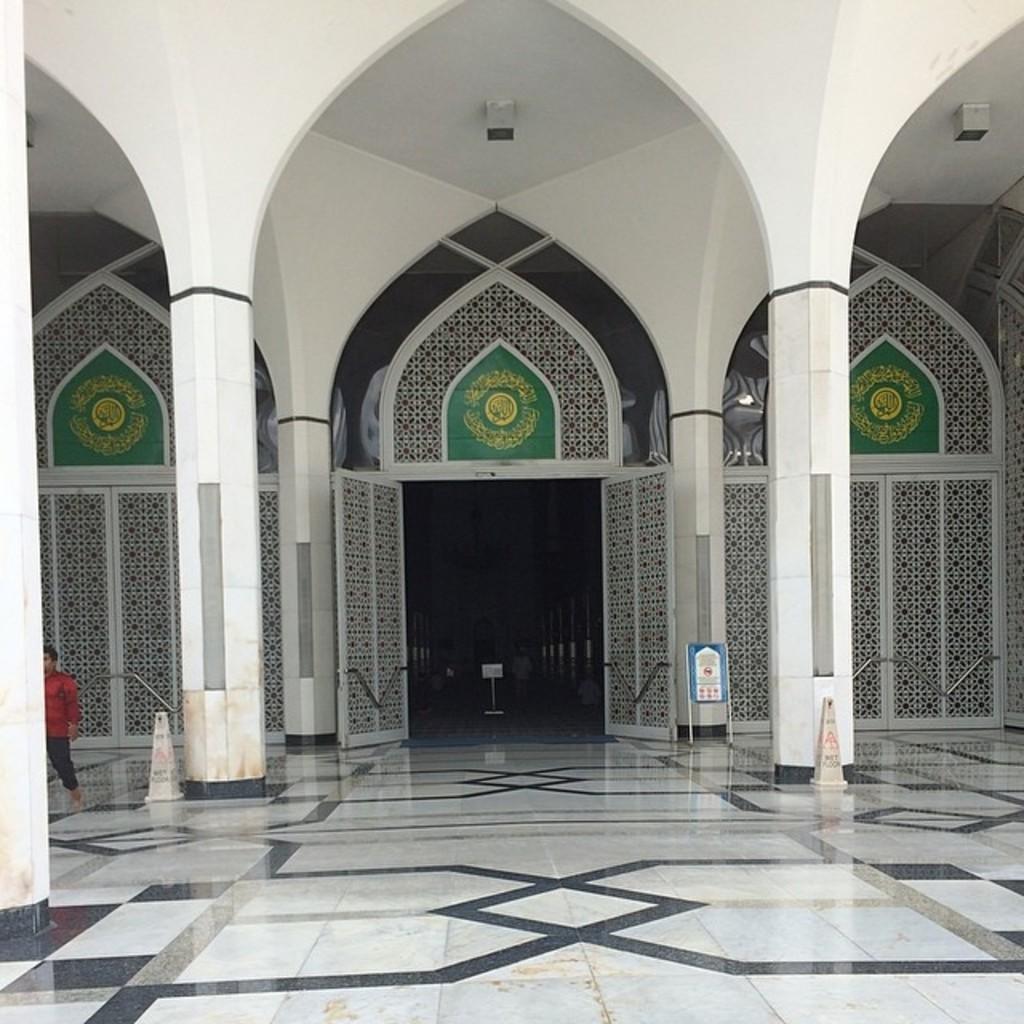Describe this image in one or two sentences. In this picture we can see a building, on the left side there is a person walking, we can see pillars in the middle, in the background there is a board, on the left side and right side there are narrow cones. 